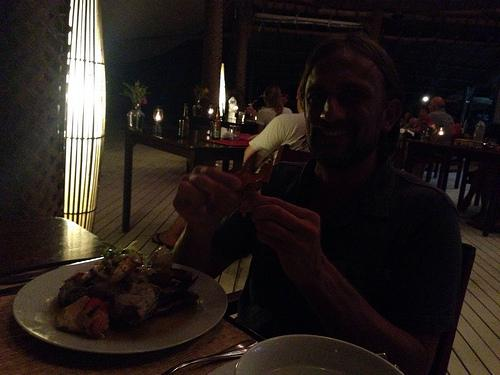Question: where is the subject of the picture seated?
Choices:
A. On a couch.
B. In a chair.
C. At a table.
D. On the grass.
Answer with the letter. Answer: C Question: what color is the plate in front of the man?
Choices:
A. Blue.
B. Purple.
C. White.
D. Green.
Answer with the letter. Answer: C Question: what corner of the photo is the plate in?
Choices:
A. Bottom left.
B. In the lower right.
C. In the  upper right.
D. In the bottom right.
Answer with the letter. Answer: A Question: what portion of the picture has the brightest light?
Choices:
A. Top right.
B. Top left.
C. Bottom left.
D. Bottom right.
Answer with the letter. Answer: B Question: how many pieces of silverware are between the plate and the bowl?
Choices:
A. Two.
B. One.
C. Three.
D. Four.
Answer with the letter. Answer: B Question: what style shoe is the person behind the man in front wearing?
Choices:
A. Flip flop.
B. Dress shoes.
C. Tennis shoes.
D. High heels.
Answer with the letter. Answer: A 